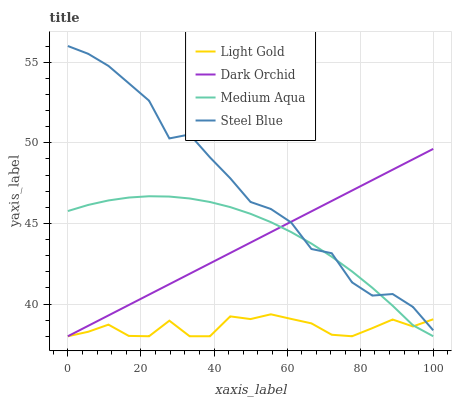Does Light Gold have the minimum area under the curve?
Answer yes or no. Yes. Does Steel Blue have the maximum area under the curve?
Answer yes or no. Yes. Does Steel Blue have the minimum area under the curve?
Answer yes or no. No. Does Light Gold have the maximum area under the curve?
Answer yes or no. No. Is Dark Orchid the smoothest?
Answer yes or no. Yes. Is Steel Blue the roughest?
Answer yes or no. Yes. Is Light Gold the smoothest?
Answer yes or no. No. Is Light Gold the roughest?
Answer yes or no. No. Does Medium Aqua have the lowest value?
Answer yes or no. Yes. Does Steel Blue have the lowest value?
Answer yes or no. No. Does Steel Blue have the highest value?
Answer yes or no. Yes. Does Light Gold have the highest value?
Answer yes or no. No. Does Steel Blue intersect Dark Orchid?
Answer yes or no. Yes. Is Steel Blue less than Dark Orchid?
Answer yes or no. No. Is Steel Blue greater than Dark Orchid?
Answer yes or no. No. 